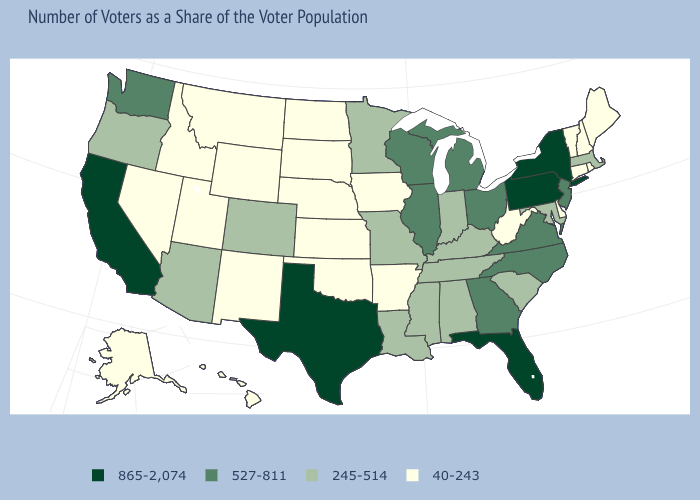Name the states that have a value in the range 40-243?
Be succinct. Alaska, Arkansas, Connecticut, Delaware, Hawaii, Idaho, Iowa, Kansas, Maine, Montana, Nebraska, Nevada, New Hampshire, New Mexico, North Dakota, Oklahoma, Rhode Island, South Dakota, Utah, Vermont, West Virginia, Wyoming. Does Connecticut have a higher value than Idaho?
Give a very brief answer. No. Name the states that have a value in the range 527-811?
Quick response, please. Georgia, Illinois, Michigan, New Jersey, North Carolina, Ohio, Virginia, Washington, Wisconsin. What is the value of Wisconsin?
Concise answer only. 527-811. What is the highest value in states that border New Hampshire?
Write a very short answer. 245-514. Which states have the lowest value in the USA?
Short answer required. Alaska, Arkansas, Connecticut, Delaware, Hawaii, Idaho, Iowa, Kansas, Maine, Montana, Nebraska, Nevada, New Hampshire, New Mexico, North Dakota, Oklahoma, Rhode Island, South Dakota, Utah, Vermont, West Virginia, Wyoming. What is the highest value in states that border Mississippi?
Quick response, please. 245-514. Among the states that border Minnesota , which have the lowest value?
Keep it brief. Iowa, North Dakota, South Dakota. What is the highest value in the West ?
Answer briefly. 865-2,074. Does New York have the lowest value in the Northeast?
Concise answer only. No. Among the states that border Massachusetts , which have the highest value?
Concise answer only. New York. What is the highest value in the MidWest ?
Write a very short answer. 527-811. Name the states that have a value in the range 40-243?
Concise answer only. Alaska, Arkansas, Connecticut, Delaware, Hawaii, Idaho, Iowa, Kansas, Maine, Montana, Nebraska, Nevada, New Hampshire, New Mexico, North Dakota, Oklahoma, Rhode Island, South Dakota, Utah, Vermont, West Virginia, Wyoming. Does Virginia have a lower value than Texas?
Quick response, please. Yes. What is the value of Louisiana?
Quick response, please. 245-514. 